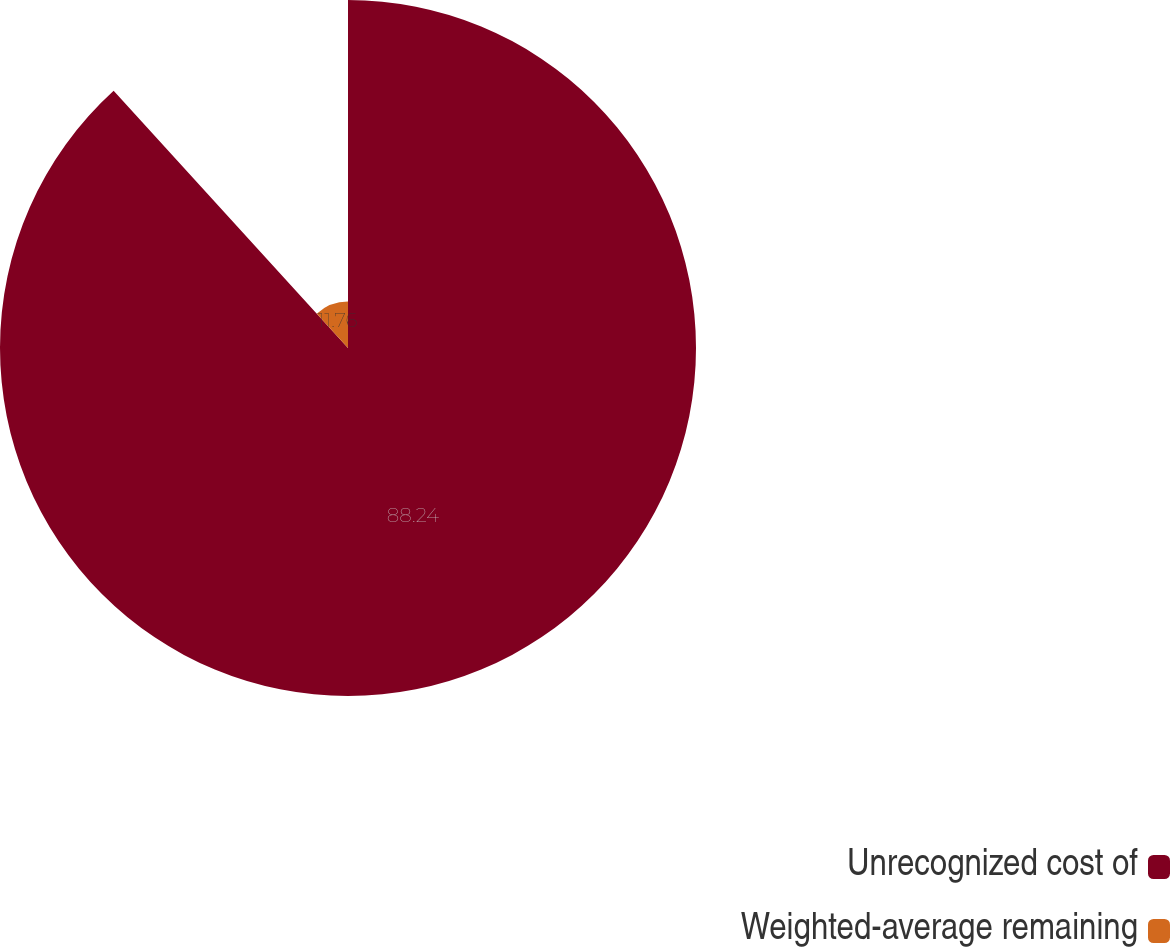<chart> <loc_0><loc_0><loc_500><loc_500><pie_chart><fcel>Unrecognized cost of<fcel>Weighted-average remaining<nl><fcel>88.24%<fcel>11.76%<nl></chart> 